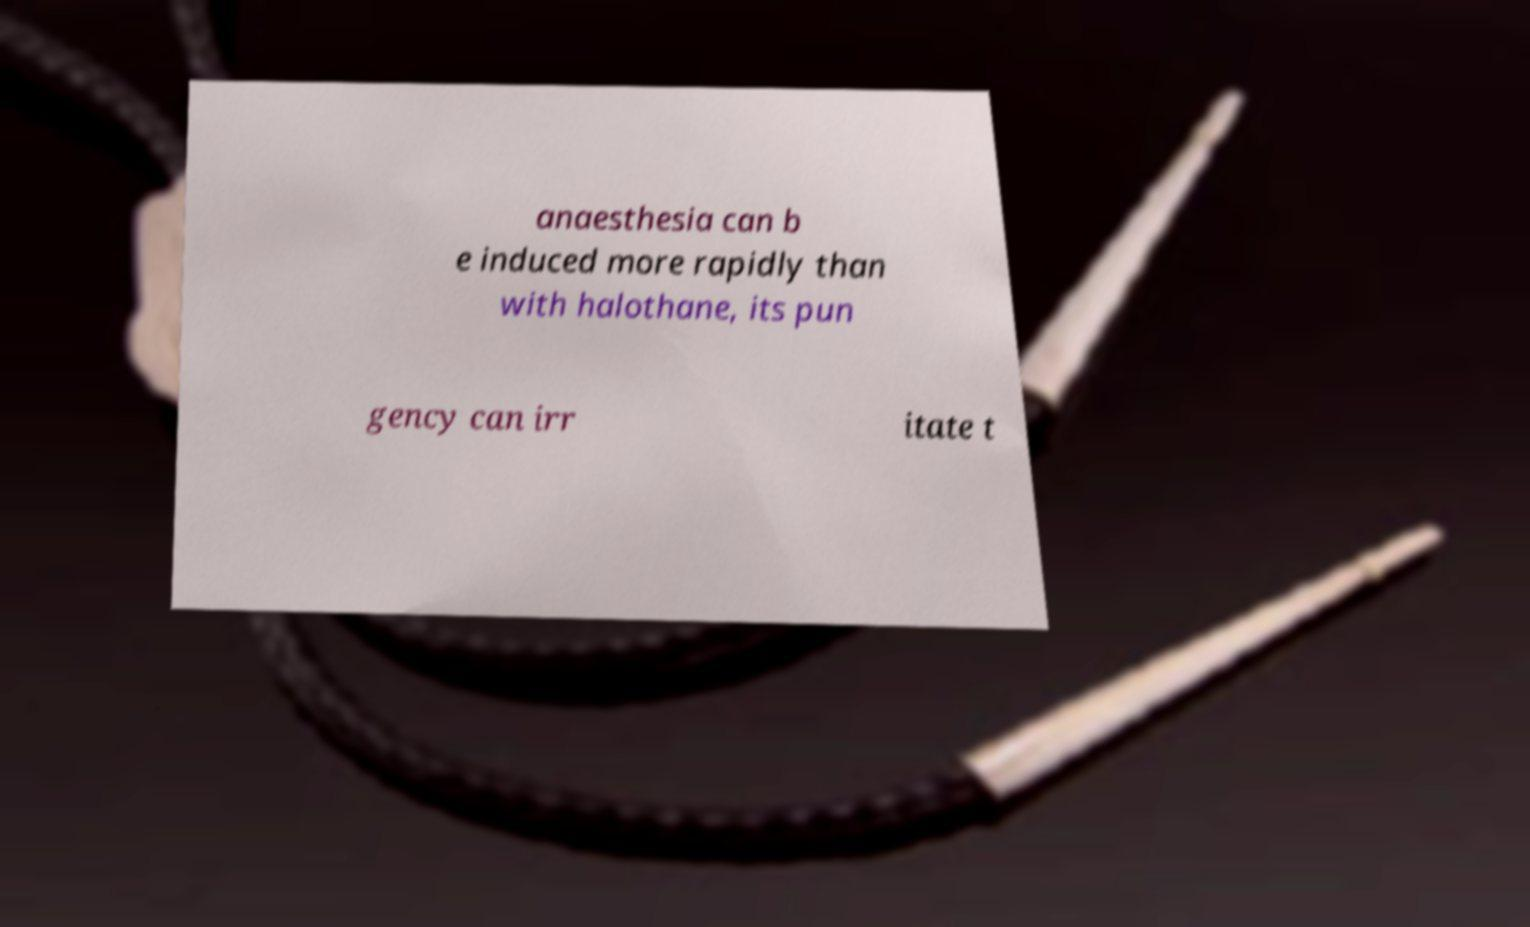There's text embedded in this image that I need extracted. Can you transcribe it verbatim? anaesthesia can b e induced more rapidly than with halothane, its pun gency can irr itate t 